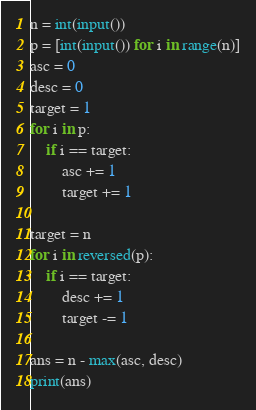Convert code to text. <code><loc_0><loc_0><loc_500><loc_500><_Python_>n = int(input())
p = [int(input()) for i in range(n)]
asc = 0
desc = 0
target = 1
for i in p:
    if i == target:
        asc += 1
        target += 1

target = n
for i in reversed(p):
    if i == target:
        desc += 1
        target -= 1

ans = n - max(asc, desc)
print(ans)</code> 